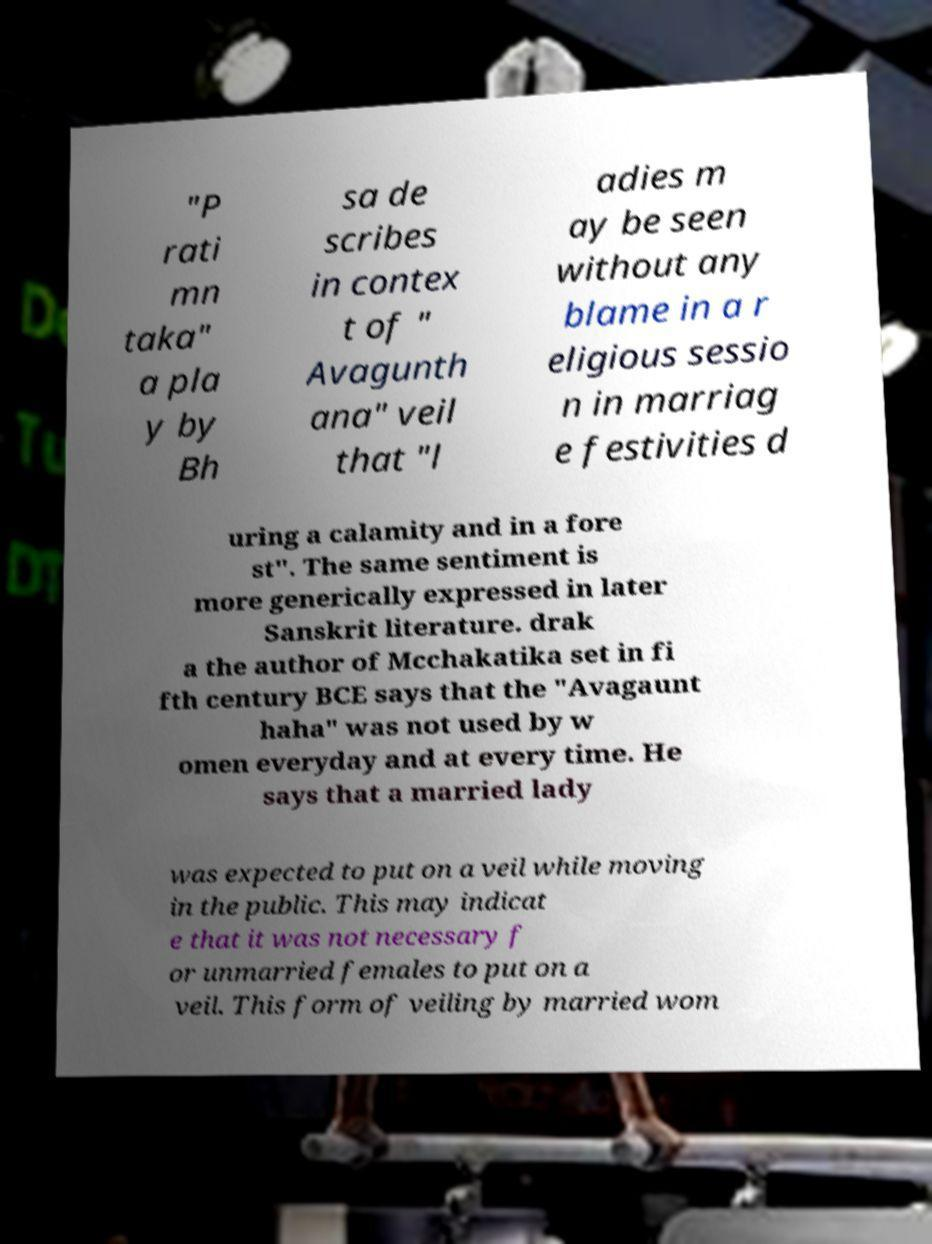Can you accurately transcribe the text from the provided image for me? "P rati mn taka" a pla y by Bh sa de scribes in contex t of " Avagunth ana" veil that "l adies m ay be seen without any blame in a r eligious sessio n in marriag e festivities d uring a calamity and in a fore st". The same sentiment is more generically expressed in later Sanskrit literature. drak a the author of Mcchakatika set in fi fth century BCE says that the "Avagaunt haha" was not used by w omen everyday and at every time. He says that a married lady was expected to put on a veil while moving in the public. This may indicat e that it was not necessary f or unmarried females to put on a veil. This form of veiling by married wom 